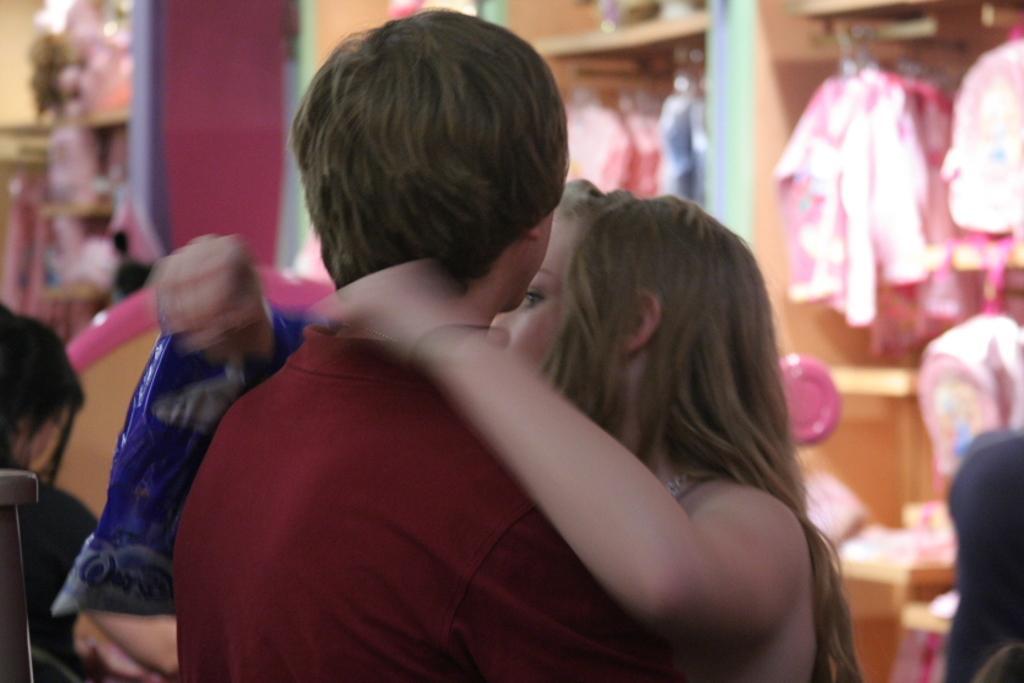In one or two sentences, can you explain what this image depicts? The boy in maroon T-shirt is standing beside the girl. Behind her, we see clothes hanged to the hangers. On the left side, we see a red color pillar. This picture is clicked in the shop. In the background, it is blurred. 